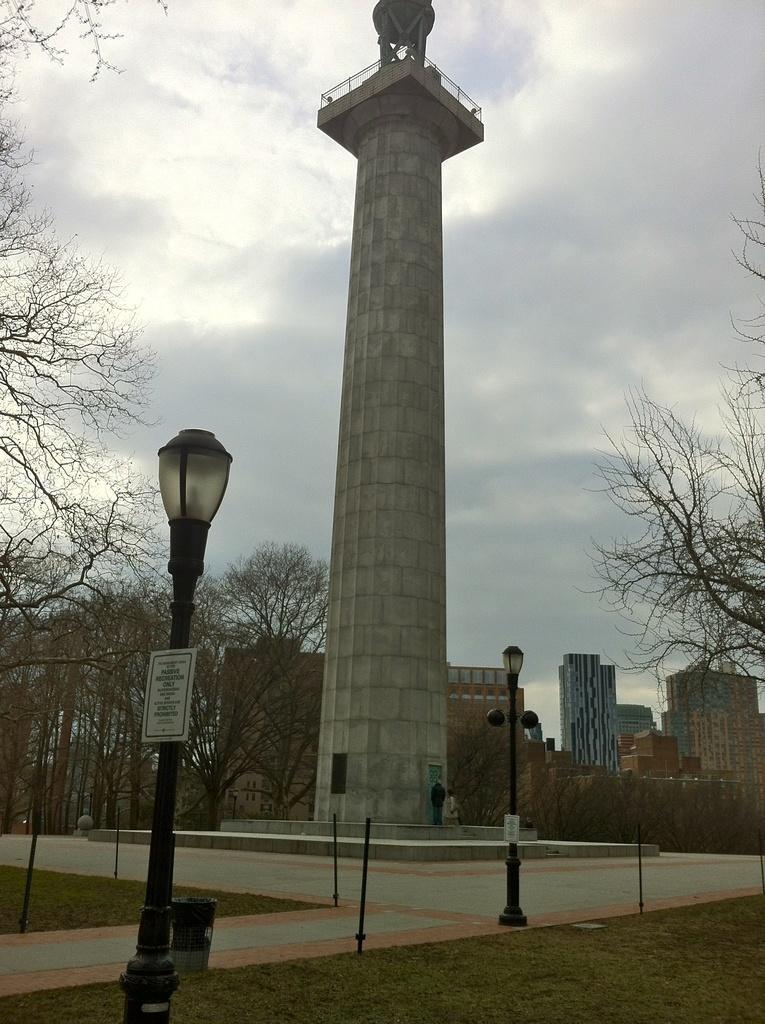How would you summarize this image in a sentence or two? In this image we can see a statue which looks like a tower and we can see two persons and there are few light poles. We can see some trees and there are few buildings in the background and at the top we can see the sky. 